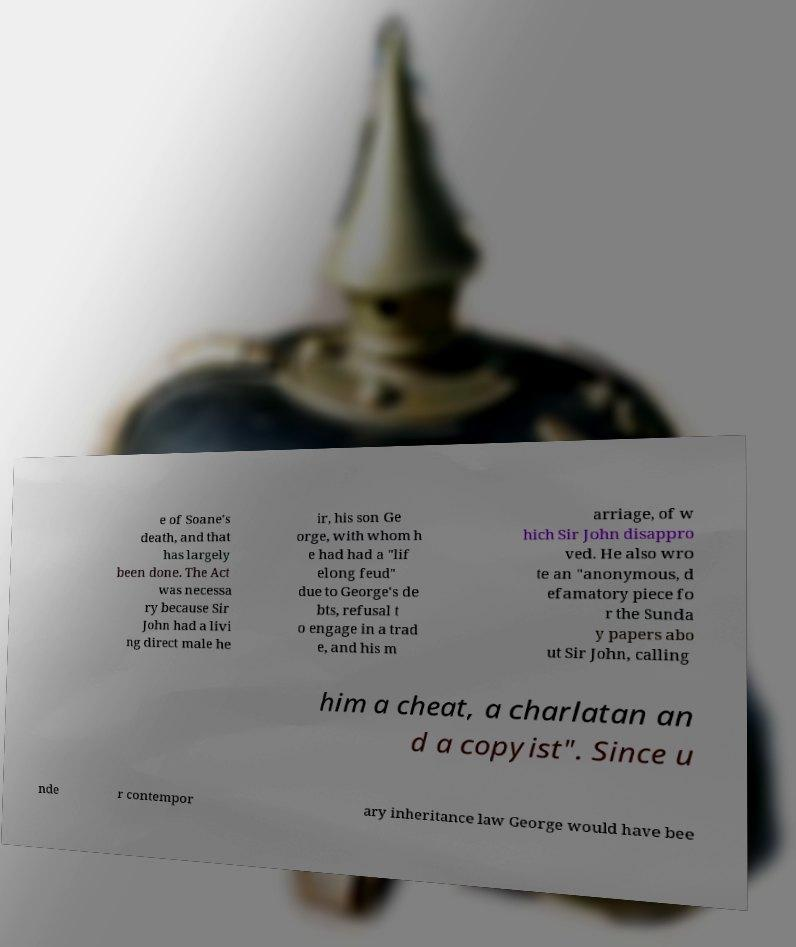I need the written content from this picture converted into text. Can you do that? e of Soane's death, and that has largely been done. The Act was necessa ry because Sir John had a livi ng direct male he ir, his son Ge orge, with whom h e had had a "lif elong feud" due to George's de bts, refusal t o engage in a trad e, and his m arriage, of w hich Sir John disappro ved. He also wro te an "anonymous, d efamatory piece fo r the Sunda y papers abo ut Sir John, calling him a cheat, a charlatan an d a copyist". Since u nde r contempor ary inheritance law George would have bee 